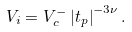Convert formula to latex. <formula><loc_0><loc_0><loc_500><loc_500>V _ { i } = V _ { c } ^ { - } \left | t _ { p } \right | ^ { - 3 \nu } .</formula> 